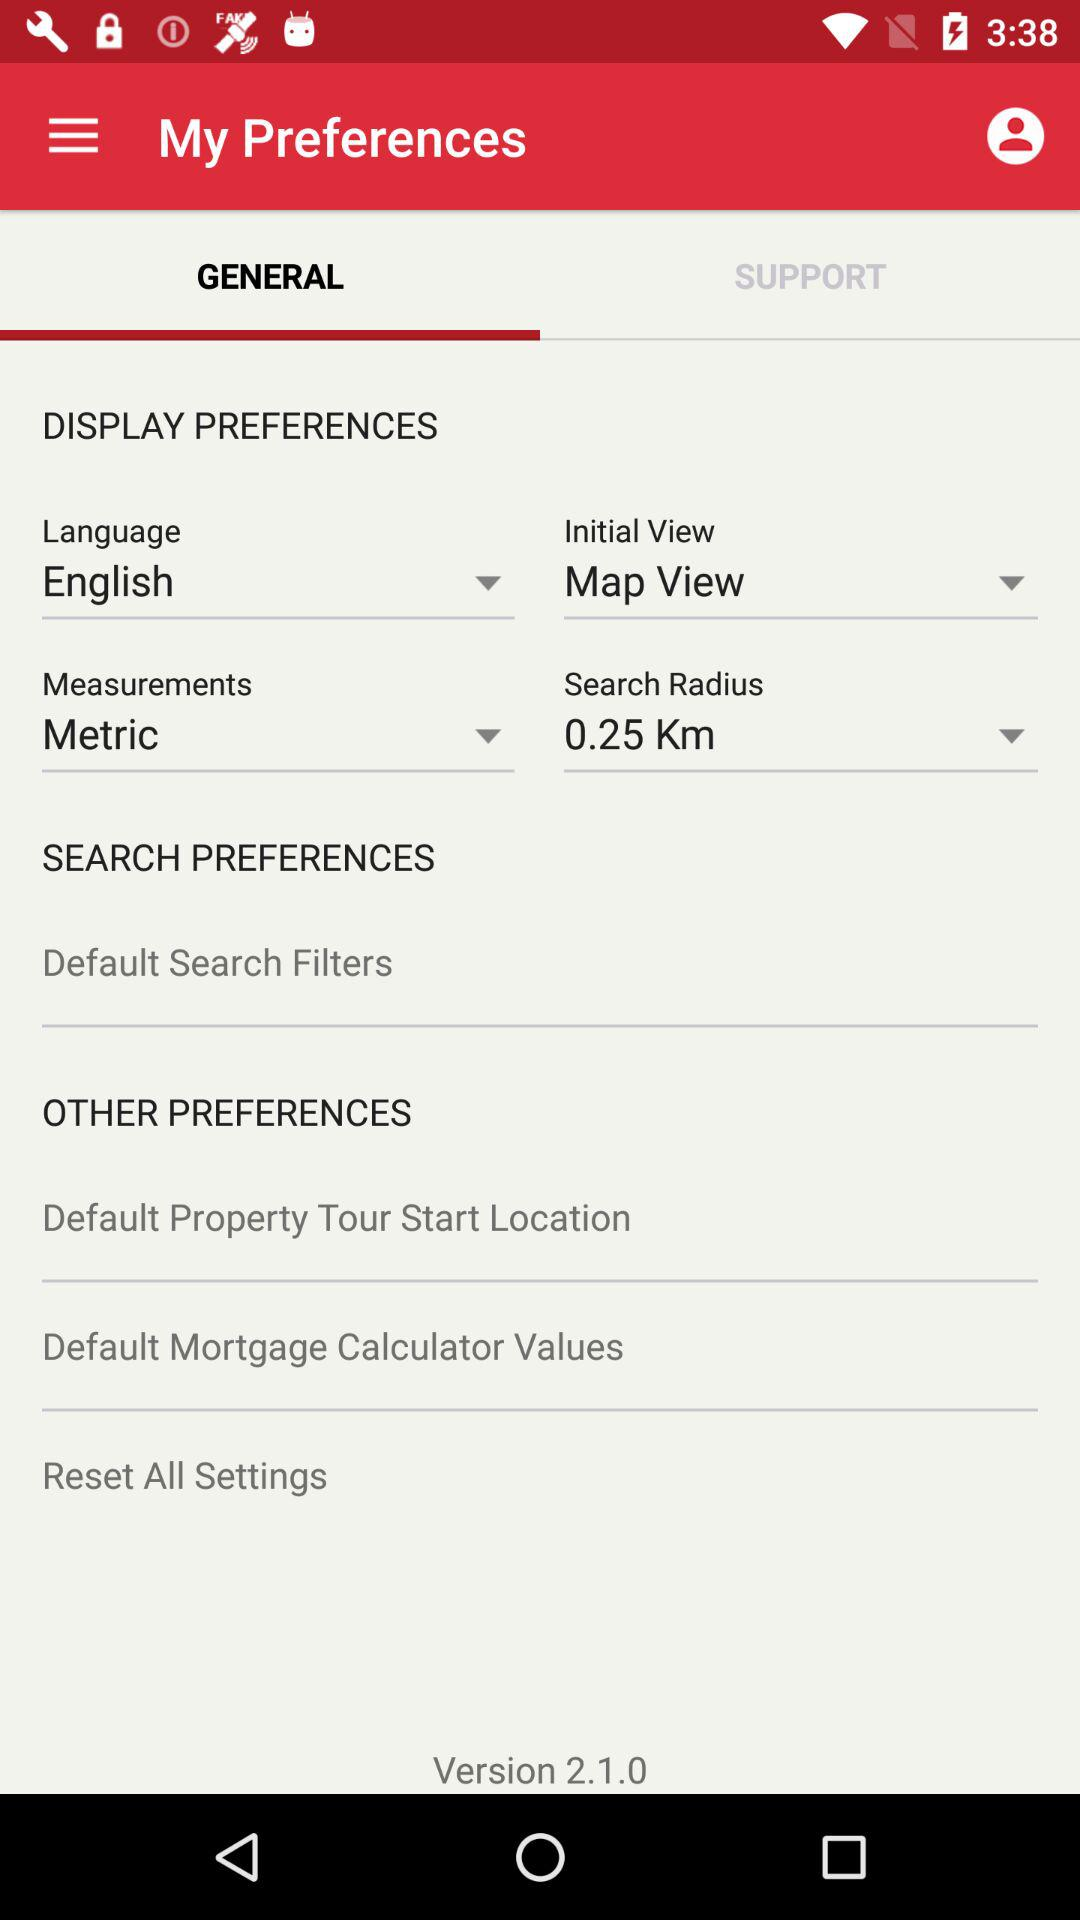What is the initial view? The initial view is "Map View". 